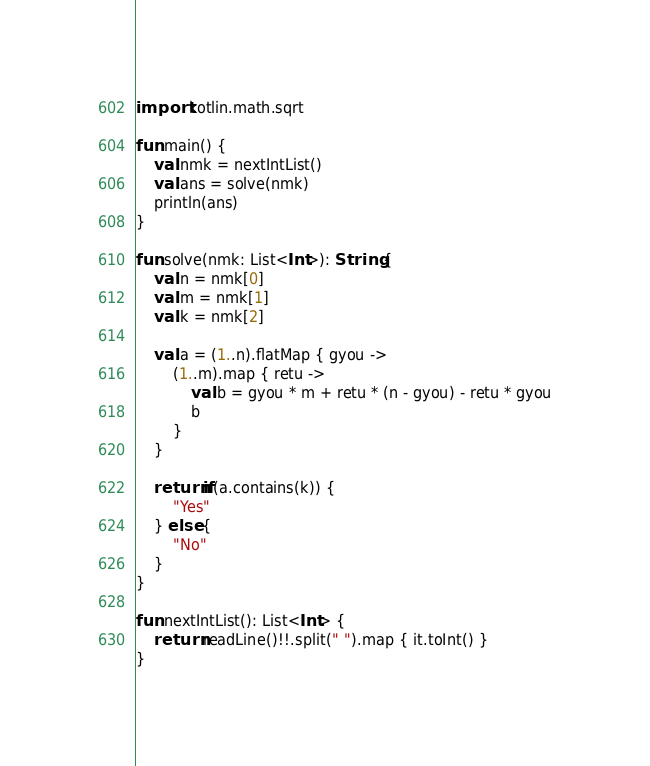Convert code to text. <code><loc_0><loc_0><loc_500><loc_500><_Kotlin_>import kotlin.math.sqrt

fun main() {
    val nmk = nextIntList()
    val ans = solve(nmk)
    println(ans)
}

fun solve(nmk: List<Int>): String {
    val n = nmk[0]
    val m = nmk[1]
    val k = nmk[2]

    val a = (1..n).flatMap { gyou ->
        (1..m).map { retu ->
            val b = gyou * m + retu * (n - gyou) - retu * gyou
            b
        }
    }

    return if(a.contains(k)) {
        "Yes"
    } else {
        "No"
    }
}

fun nextIntList(): List<Int> {
    return readLine()!!.split(" ").map { it.toInt() }
}</code> 